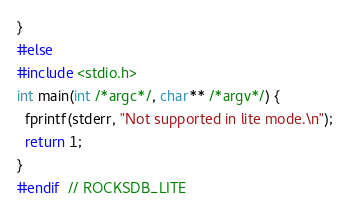Convert code to text. <code><loc_0><loc_0><loc_500><loc_500><_C++_>}
#else
#include <stdio.h>
int main(int /*argc*/, char** /*argv*/) {
  fprintf(stderr, "Not supported in lite mode.\n");
  return 1;
}
#endif  // ROCKSDB_LITE
</code> 